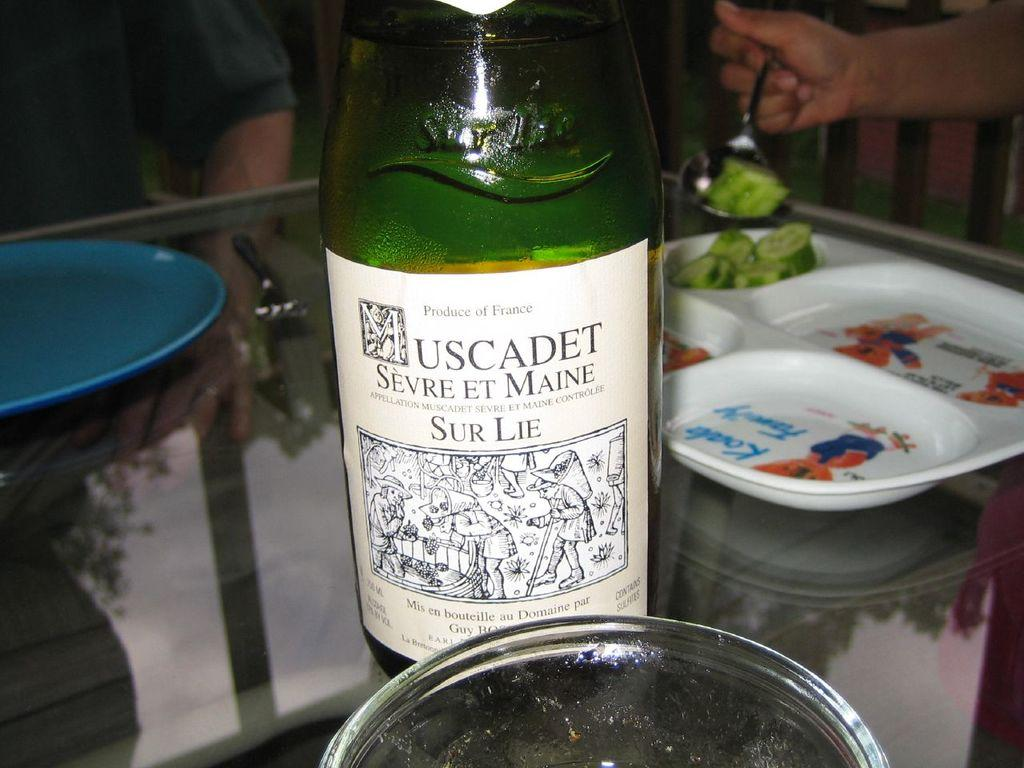<image>
Share a concise interpretation of the image provided. A bottle labels has Muscadet Sevreet maine and it is a product of France 